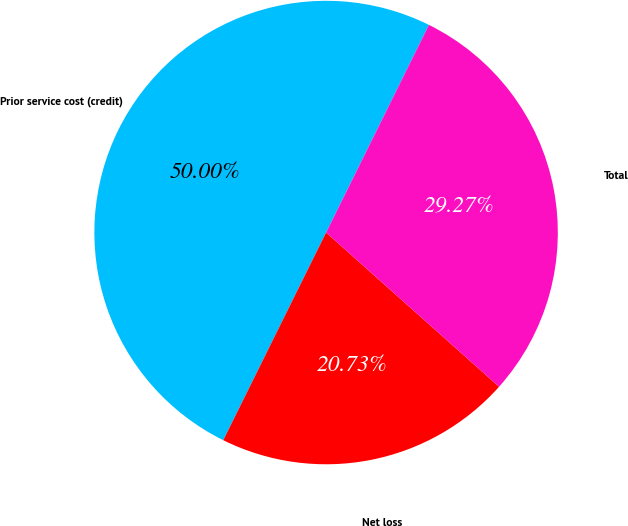Convert chart to OTSL. <chart><loc_0><loc_0><loc_500><loc_500><pie_chart><fcel>Prior service cost (credit)<fcel>Net loss<fcel>Total<nl><fcel>50.0%<fcel>20.73%<fcel>29.27%<nl></chart> 